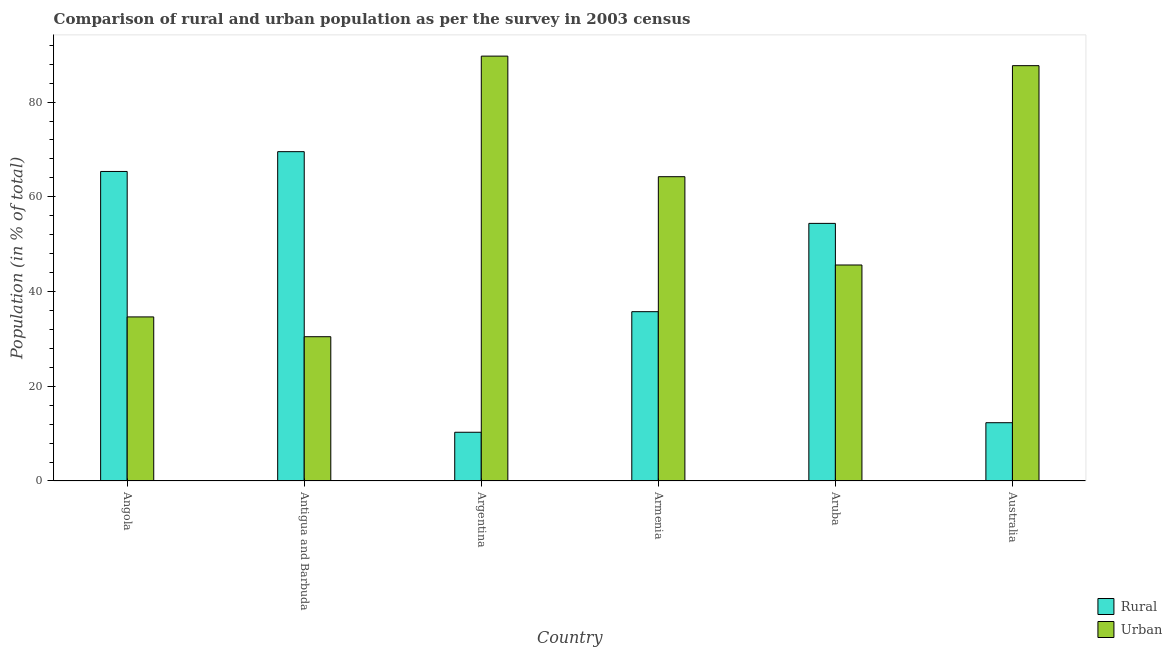Are the number of bars per tick equal to the number of legend labels?
Your answer should be very brief. Yes. Are the number of bars on each tick of the X-axis equal?
Your answer should be very brief. Yes. How many bars are there on the 2nd tick from the right?
Offer a very short reply. 2. What is the label of the 2nd group of bars from the left?
Give a very brief answer. Antigua and Barbuda. In how many cases, is the number of bars for a given country not equal to the number of legend labels?
Keep it short and to the point. 0. What is the rural population in Armenia?
Your answer should be compact. 35.75. Across all countries, what is the maximum rural population?
Provide a short and direct response. 69.53. Across all countries, what is the minimum urban population?
Your answer should be compact. 30.46. In which country was the rural population maximum?
Keep it short and to the point. Antigua and Barbuda. In which country was the urban population minimum?
Offer a terse response. Antigua and Barbuda. What is the total urban population in the graph?
Keep it short and to the point. 352.37. What is the difference between the rural population in Armenia and that in Aruba?
Your response must be concise. -18.64. What is the difference between the urban population in Argentina and the rural population in Aruba?
Give a very brief answer. 35.32. What is the average urban population per country?
Make the answer very short. 58.73. What is the difference between the rural population and urban population in Australia?
Offer a terse response. -75.39. In how many countries, is the rural population greater than 68 %?
Make the answer very short. 1. What is the ratio of the rural population in Antigua and Barbuda to that in Armenia?
Keep it short and to the point. 1.95. Is the rural population in Angola less than that in Armenia?
Offer a terse response. No. Is the difference between the rural population in Angola and Aruba greater than the difference between the urban population in Angola and Aruba?
Ensure brevity in your answer.  Yes. What is the difference between the highest and the second highest urban population?
Provide a short and direct response. 2.02. What is the difference between the highest and the lowest rural population?
Give a very brief answer. 59.24. Is the sum of the rural population in Angola and Argentina greater than the maximum urban population across all countries?
Your answer should be compact. No. What does the 2nd bar from the left in Angola represents?
Provide a succinct answer. Urban. What does the 1st bar from the right in Australia represents?
Your response must be concise. Urban. How many bars are there?
Offer a terse response. 12. Are all the bars in the graph horizontal?
Offer a terse response. No. Are the values on the major ticks of Y-axis written in scientific E-notation?
Your answer should be compact. No. Does the graph contain grids?
Your response must be concise. No. Where does the legend appear in the graph?
Your answer should be very brief. Bottom right. How many legend labels are there?
Your answer should be compact. 2. What is the title of the graph?
Give a very brief answer. Comparison of rural and urban population as per the survey in 2003 census. What is the label or title of the Y-axis?
Your response must be concise. Population (in % of total). What is the Population (in % of total) of Rural in Angola?
Your answer should be very brief. 65.36. What is the Population (in % of total) of Urban in Angola?
Offer a very short reply. 34.65. What is the Population (in % of total) in Rural in Antigua and Barbuda?
Give a very brief answer. 69.53. What is the Population (in % of total) of Urban in Antigua and Barbuda?
Your answer should be compact. 30.46. What is the Population (in % of total) of Rural in Argentina?
Your response must be concise. 10.29. What is the Population (in % of total) in Urban in Argentina?
Offer a terse response. 89.71. What is the Population (in % of total) of Rural in Armenia?
Your answer should be compact. 35.75. What is the Population (in % of total) in Urban in Armenia?
Provide a succinct answer. 64.25. What is the Population (in % of total) of Rural in Aruba?
Give a very brief answer. 54.39. What is the Population (in % of total) in Urban in Aruba?
Offer a terse response. 45.61. What is the Population (in % of total) in Rural in Australia?
Your response must be concise. 12.3. What is the Population (in % of total) in Urban in Australia?
Your answer should be compact. 87.69. Across all countries, what is the maximum Population (in % of total) of Rural?
Your answer should be compact. 69.53. Across all countries, what is the maximum Population (in % of total) of Urban?
Your answer should be very brief. 89.71. Across all countries, what is the minimum Population (in % of total) of Rural?
Provide a succinct answer. 10.29. Across all countries, what is the minimum Population (in % of total) of Urban?
Provide a short and direct response. 30.46. What is the total Population (in % of total) of Rural in the graph?
Provide a succinct answer. 247.63. What is the total Population (in % of total) of Urban in the graph?
Keep it short and to the point. 352.37. What is the difference between the Population (in % of total) of Rural in Angola and that in Antigua and Barbuda?
Your answer should be compact. -4.18. What is the difference between the Population (in % of total) in Urban in Angola and that in Antigua and Barbuda?
Your response must be concise. 4.18. What is the difference between the Population (in % of total) of Rural in Angola and that in Argentina?
Your answer should be very brief. 55.06. What is the difference between the Population (in % of total) of Urban in Angola and that in Argentina?
Ensure brevity in your answer.  -55.06. What is the difference between the Population (in % of total) of Rural in Angola and that in Armenia?
Ensure brevity in your answer.  29.61. What is the difference between the Population (in % of total) in Urban in Angola and that in Armenia?
Your answer should be very brief. -29.61. What is the difference between the Population (in % of total) in Rural in Angola and that in Aruba?
Your answer should be compact. 10.96. What is the difference between the Population (in % of total) in Urban in Angola and that in Aruba?
Provide a short and direct response. -10.96. What is the difference between the Population (in % of total) of Rural in Angola and that in Australia?
Your response must be concise. 53.05. What is the difference between the Population (in % of total) of Urban in Angola and that in Australia?
Keep it short and to the point. -53.05. What is the difference between the Population (in % of total) in Rural in Antigua and Barbuda and that in Argentina?
Your answer should be very brief. 59.24. What is the difference between the Population (in % of total) in Urban in Antigua and Barbuda and that in Argentina?
Ensure brevity in your answer.  -59.24. What is the difference between the Population (in % of total) of Rural in Antigua and Barbuda and that in Armenia?
Offer a very short reply. 33.78. What is the difference between the Population (in % of total) in Urban in Antigua and Barbuda and that in Armenia?
Make the answer very short. -33.78. What is the difference between the Population (in % of total) in Rural in Antigua and Barbuda and that in Aruba?
Your answer should be very brief. 15.14. What is the difference between the Population (in % of total) in Urban in Antigua and Barbuda and that in Aruba?
Offer a terse response. -15.14. What is the difference between the Population (in % of total) in Rural in Antigua and Barbuda and that in Australia?
Offer a terse response. 57.23. What is the difference between the Population (in % of total) of Urban in Antigua and Barbuda and that in Australia?
Your answer should be compact. -57.23. What is the difference between the Population (in % of total) of Rural in Argentina and that in Armenia?
Your response must be concise. -25.46. What is the difference between the Population (in % of total) in Urban in Argentina and that in Armenia?
Offer a very short reply. 25.46. What is the difference between the Population (in % of total) of Rural in Argentina and that in Aruba?
Provide a short and direct response. -44.1. What is the difference between the Population (in % of total) of Urban in Argentina and that in Aruba?
Give a very brief answer. 44.1. What is the difference between the Population (in % of total) in Rural in Argentina and that in Australia?
Your answer should be compact. -2.02. What is the difference between the Population (in % of total) of Urban in Argentina and that in Australia?
Your answer should be compact. 2.02. What is the difference between the Population (in % of total) of Rural in Armenia and that in Aruba?
Provide a short and direct response. -18.64. What is the difference between the Population (in % of total) of Urban in Armenia and that in Aruba?
Offer a very short reply. 18.64. What is the difference between the Population (in % of total) of Rural in Armenia and that in Australia?
Your response must be concise. 23.45. What is the difference between the Population (in % of total) in Urban in Armenia and that in Australia?
Offer a terse response. -23.45. What is the difference between the Population (in % of total) of Rural in Aruba and that in Australia?
Your response must be concise. 42.09. What is the difference between the Population (in % of total) of Urban in Aruba and that in Australia?
Your answer should be compact. -42.09. What is the difference between the Population (in % of total) of Rural in Angola and the Population (in % of total) of Urban in Antigua and Barbuda?
Provide a succinct answer. 34.89. What is the difference between the Population (in % of total) of Rural in Angola and the Population (in % of total) of Urban in Argentina?
Ensure brevity in your answer.  -24.36. What is the difference between the Population (in % of total) of Rural in Angola and the Population (in % of total) of Urban in Armenia?
Your response must be concise. 1.1. What is the difference between the Population (in % of total) of Rural in Angola and the Population (in % of total) of Urban in Aruba?
Offer a very short reply. 19.75. What is the difference between the Population (in % of total) of Rural in Angola and the Population (in % of total) of Urban in Australia?
Provide a short and direct response. -22.34. What is the difference between the Population (in % of total) of Rural in Antigua and Barbuda and the Population (in % of total) of Urban in Argentina?
Ensure brevity in your answer.  -20.18. What is the difference between the Population (in % of total) in Rural in Antigua and Barbuda and the Population (in % of total) in Urban in Armenia?
Your response must be concise. 5.29. What is the difference between the Population (in % of total) in Rural in Antigua and Barbuda and the Population (in % of total) in Urban in Aruba?
Your answer should be very brief. 23.93. What is the difference between the Population (in % of total) of Rural in Antigua and Barbuda and the Population (in % of total) of Urban in Australia?
Provide a succinct answer. -18.16. What is the difference between the Population (in % of total) in Rural in Argentina and the Population (in % of total) in Urban in Armenia?
Provide a succinct answer. -53.96. What is the difference between the Population (in % of total) in Rural in Argentina and the Population (in % of total) in Urban in Aruba?
Provide a succinct answer. -35.32. What is the difference between the Population (in % of total) of Rural in Argentina and the Population (in % of total) of Urban in Australia?
Your response must be concise. -77.41. What is the difference between the Population (in % of total) in Rural in Armenia and the Population (in % of total) in Urban in Aruba?
Make the answer very short. -9.86. What is the difference between the Population (in % of total) of Rural in Armenia and the Population (in % of total) of Urban in Australia?
Make the answer very short. -51.95. What is the difference between the Population (in % of total) of Rural in Aruba and the Population (in % of total) of Urban in Australia?
Provide a succinct answer. -33.3. What is the average Population (in % of total) of Rural per country?
Give a very brief answer. 41.27. What is the average Population (in % of total) in Urban per country?
Provide a short and direct response. 58.73. What is the difference between the Population (in % of total) in Rural and Population (in % of total) in Urban in Angola?
Your answer should be compact. 30.71. What is the difference between the Population (in % of total) of Rural and Population (in % of total) of Urban in Antigua and Barbuda?
Offer a terse response. 39.07. What is the difference between the Population (in % of total) of Rural and Population (in % of total) of Urban in Argentina?
Provide a succinct answer. -79.42. What is the difference between the Population (in % of total) of Rural and Population (in % of total) of Urban in Armenia?
Give a very brief answer. -28.5. What is the difference between the Population (in % of total) in Rural and Population (in % of total) in Urban in Aruba?
Ensure brevity in your answer.  8.79. What is the difference between the Population (in % of total) of Rural and Population (in % of total) of Urban in Australia?
Offer a very short reply. -75.39. What is the ratio of the Population (in % of total) of Rural in Angola to that in Antigua and Barbuda?
Give a very brief answer. 0.94. What is the ratio of the Population (in % of total) of Urban in Angola to that in Antigua and Barbuda?
Provide a short and direct response. 1.14. What is the ratio of the Population (in % of total) in Rural in Angola to that in Argentina?
Your answer should be very brief. 6.35. What is the ratio of the Population (in % of total) in Urban in Angola to that in Argentina?
Offer a terse response. 0.39. What is the ratio of the Population (in % of total) in Rural in Angola to that in Armenia?
Your answer should be compact. 1.83. What is the ratio of the Population (in % of total) of Urban in Angola to that in Armenia?
Provide a succinct answer. 0.54. What is the ratio of the Population (in % of total) in Rural in Angola to that in Aruba?
Provide a succinct answer. 1.2. What is the ratio of the Population (in % of total) in Urban in Angola to that in Aruba?
Offer a terse response. 0.76. What is the ratio of the Population (in % of total) of Rural in Angola to that in Australia?
Give a very brief answer. 5.31. What is the ratio of the Population (in % of total) of Urban in Angola to that in Australia?
Provide a succinct answer. 0.4. What is the ratio of the Population (in % of total) of Rural in Antigua and Barbuda to that in Argentina?
Your answer should be compact. 6.76. What is the ratio of the Population (in % of total) in Urban in Antigua and Barbuda to that in Argentina?
Offer a very short reply. 0.34. What is the ratio of the Population (in % of total) in Rural in Antigua and Barbuda to that in Armenia?
Offer a terse response. 1.95. What is the ratio of the Population (in % of total) of Urban in Antigua and Barbuda to that in Armenia?
Provide a short and direct response. 0.47. What is the ratio of the Population (in % of total) of Rural in Antigua and Barbuda to that in Aruba?
Keep it short and to the point. 1.28. What is the ratio of the Population (in % of total) of Urban in Antigua and Barbuda to that in Aruba?
Make the answer very short. 0.67. What is the ratio of the Population (in % of total) in Rural in Antigua and Barbuda to that in Australia?
Provide a short and direct response. 5.65. What is the ratio of the Population (in % of total) of Urban in Antigua and Barbuda to that in Australia?
Provide a succinct answer. 0.35. What is the ratio of the Population (in % of total) of Rural in Argentina to that in Armenia?
Make the answer very short. 0.29. What is the ratio of the Population (in % of total) of Urban in Argentina to that in Armenia?
Give a very brief answer. 1.4. What is the ratio of the Population (in % of total) in Rural in Argentina to that in Aruba?
Provide a succinct answer. 0.19. What is the ratio of the Population (in % of total) in Urban in Argentina to that in Aruba?
Offer a very short reply. 1.97. What is the ratio of the Population (in % of total) in Rural in Argentina to that in Australia?
Your answer should be compact. 0.84. What is the ratio of the Population (in % of total) in Urban in Argentina to that in Australia?
Make the answer very short. 1.02. What is the ratio of the Population (in % of total) in Rural in Armenia to that in Aruba?
Offer a terse response. 0.66. What is the ratio of the Population (in % of total) of Urban in Armenia to that in Aruba?
Your response must be concise. 1.41. What is the ratio of the Population (in % of total) of Rural in Armenia to that in Australia?
Offer a very short reply. 2.91. What is the ratio of the Population (in % of total) in Urban in Armenia to that in Australia?
Provide a short and direct response. 0.73. What is the ratio of the Population (in % of total) of Rural in Aruba to that in Australia?
Your answer should be compact. 4.42. What is the ratio of the Population (in % of total) in Urban in Aruba to that in Australia?
Your answer should be very brief. 0.52. What is the difference between the highest and the second highest Population (in % of total) in Rural?
Your response must be concise. 4.18. What is the difference between the highest and the second highest Population (in % of total) in Urban?
Provide a short and direct response. 2.02. What is the difference between the highest and the lowest Population (in % of total) of Rural?
Keep it short and to the point. 59.24. What is the difference between the highest and the lowest Population (in % of total) in Urban?
Your answer should be very brief. 59.24. 